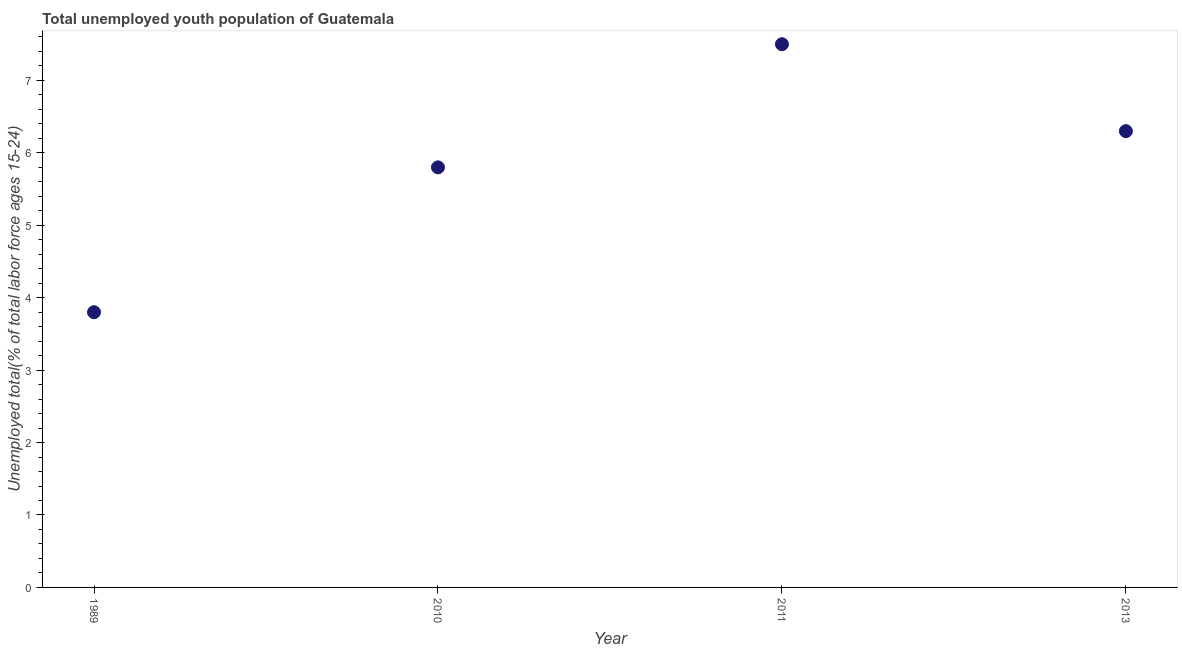What is the unemployed youth in 2010?
Your response must be concise. 5.8. Across all years, what is the maximum unemployed youth?
Ensure brevity in your answer.  7.5. Across all years, what is the minimum unemployed youth?
Give a very brief answer. 3.8. In which year was the unemployed youth maximum?
Your answer should be very brief. 2011. What is the sum of the unemployed youth?
Your response must be concise. 23.4. What is the difference between the unemployed youth in 2010 and 2011?
Make the answer very short. -1.7. What is the average unemployed youth per year?
Provide a succinct answer. 5.85. What is the median unemployed youth?
Offer a terse response. 6.05. In how many years, is the unemployed youth greater than 2.6 %?
Provide a succinct answer. 4. What is the ratio of the unemployed youth in 1989 to that in 2011?
Your answer should be very brief. 0.51. What is the difference between the highest and the second highest unemployed youth?
Make the answer very short. 1.2. Is the sum of the unemployed youth in 1989 and 2013 greater than the maximum unemployed youth across all years?
Your answer should be compact. Yes. What is the difference between the highest and the lowest unemployed youth?
Ensure brevity in your answer.  3.7. How many dotlines are there?
Your answer should be very brief. 1. What is the difference between two consecutive major ticks on the Y-axis?
Your answer should be compact. 1. Are the values on the major ticks of Y-axis written in scientific E-notation?
Your answer should be very brief. No. What is the title of the graph?
Your answer should be compact. Total unemployed youth population of Guatemala. What is the label or title of the Y-axis?
Offer a very short reply. Unemployed total(% of total labor force ages 15-24). What is the Unemployed total(% of total labor force ages 15-24) in 1989?
Your answer should be very brief. 3.8. What is the Unemployed total(% of total labor force ages 15-24) in 2010?
Give a very brief answer. 5.8. What is the Unemployed total(% of total labor force ages 15-24) in 2011?
Your response must be concise. 7.5. What is the Unemployed total(% of total labor force ages 15-24) in 2013?
Your answer should be compact. 6.3. What is the difference between the Unemployed total(% of total labor force ages 15-24) in 1989 and 2011?
Offer a terse response. -3.7. What is the difference between the Unemployed total(% of total labor force ages 15-24) in 1989 and 2013?
Provide a succinct answer. -2.5. What is the difference between the Unemployed total(% of total labor force ages 15-24) in 2010 and 2011?
Your answer should be very brief. -1.7. What is the difference between the Unemployed total(% of total labor force ages 15-24) in 2011 and 2013?
Provide a short and direct response. 1.2. What is the ratio of the Unemployed total(% of total labor force ages 15-24) in 1989 to that in 2010?
Provide a succinct answer. 0.66. What is the ratio of the Unemployed total(% of total labor force ages 15-24) in 1989 to that in 2011?
Ensure brevity in your answer.  0.51. What is the ratio of the Unemployed total(% of total labor force ages 15-24) in 1989 to that in 2013?
Give a very brief answer. 0.6. What is the ratio of the Unemployed total(% of total labor force ages 15-24) in 2010 to that in 2011?
Provide a succinct answer. 0.77. What is the ratio of the Unemployed total(% of total labor force ages 15-24) in 2010 to that in 2013?
Ensure brevity in your answer.  0.92. What is the ratio of the Unemployed total(% of total labor force ages 15-24) in 2011 to that in 2013?
Offer a very short reply. 1.19. 